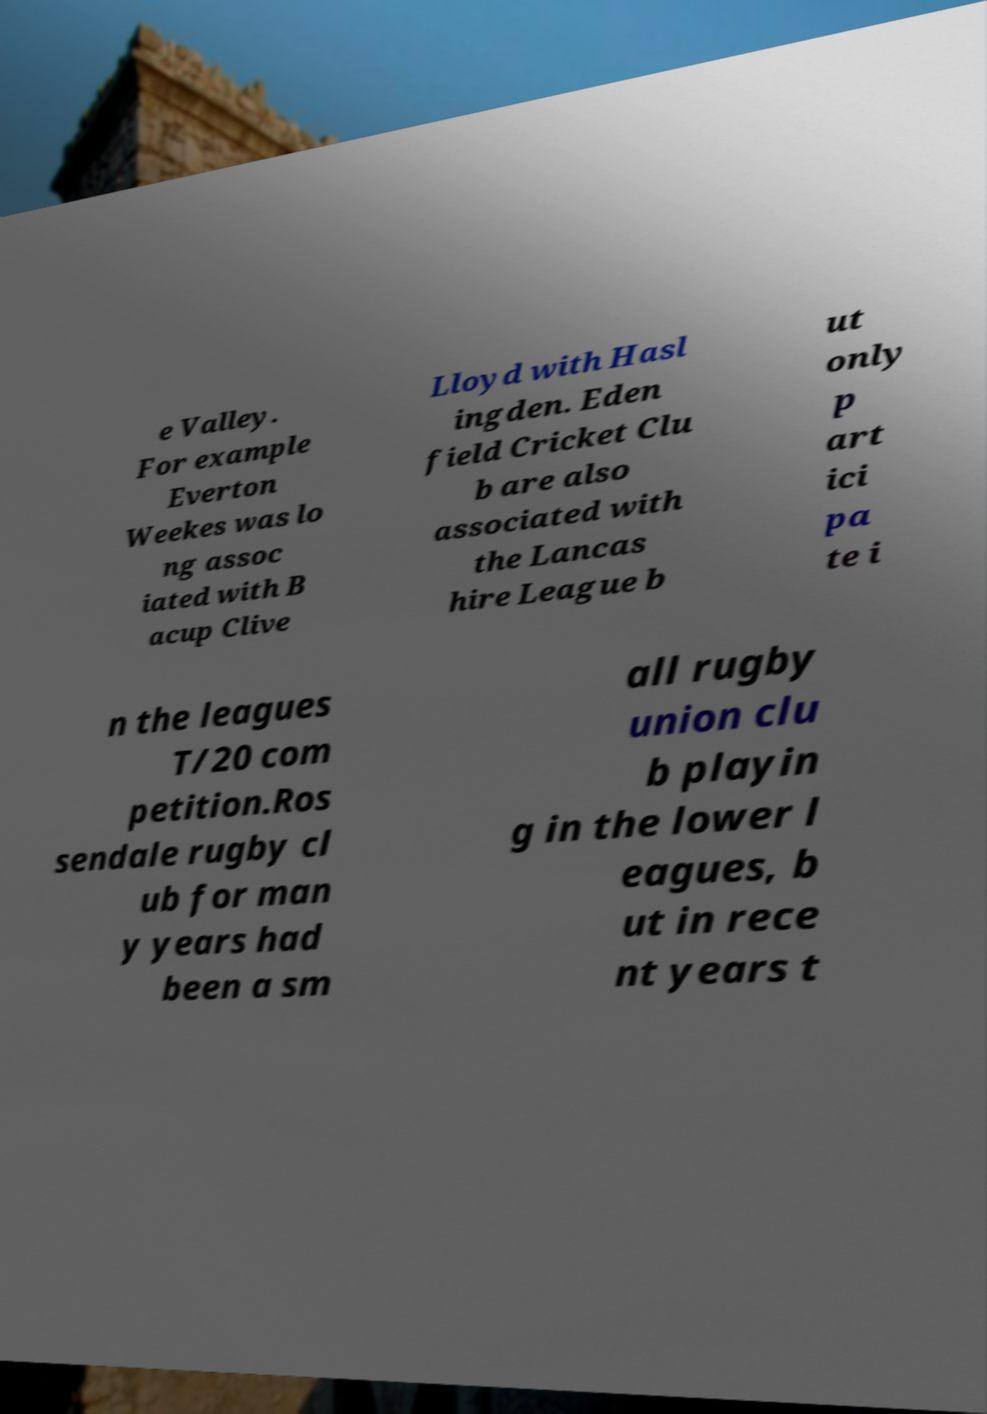Please identify and transcribe the text found in this image. e Valley. For example Everton Weekes was lo ng assoc iated with B acup Clive Lloyd with Hasl ingden. Eden field Cricket Clu b are also associated with the Lancas hire League b ut only p art ici pa te i n the leagues T/20 com petition.Ros sendale rugby cl ub for man y years had been a sm all rugby union clu b playin g in the lower l eagues, b ut in rece nt years t 